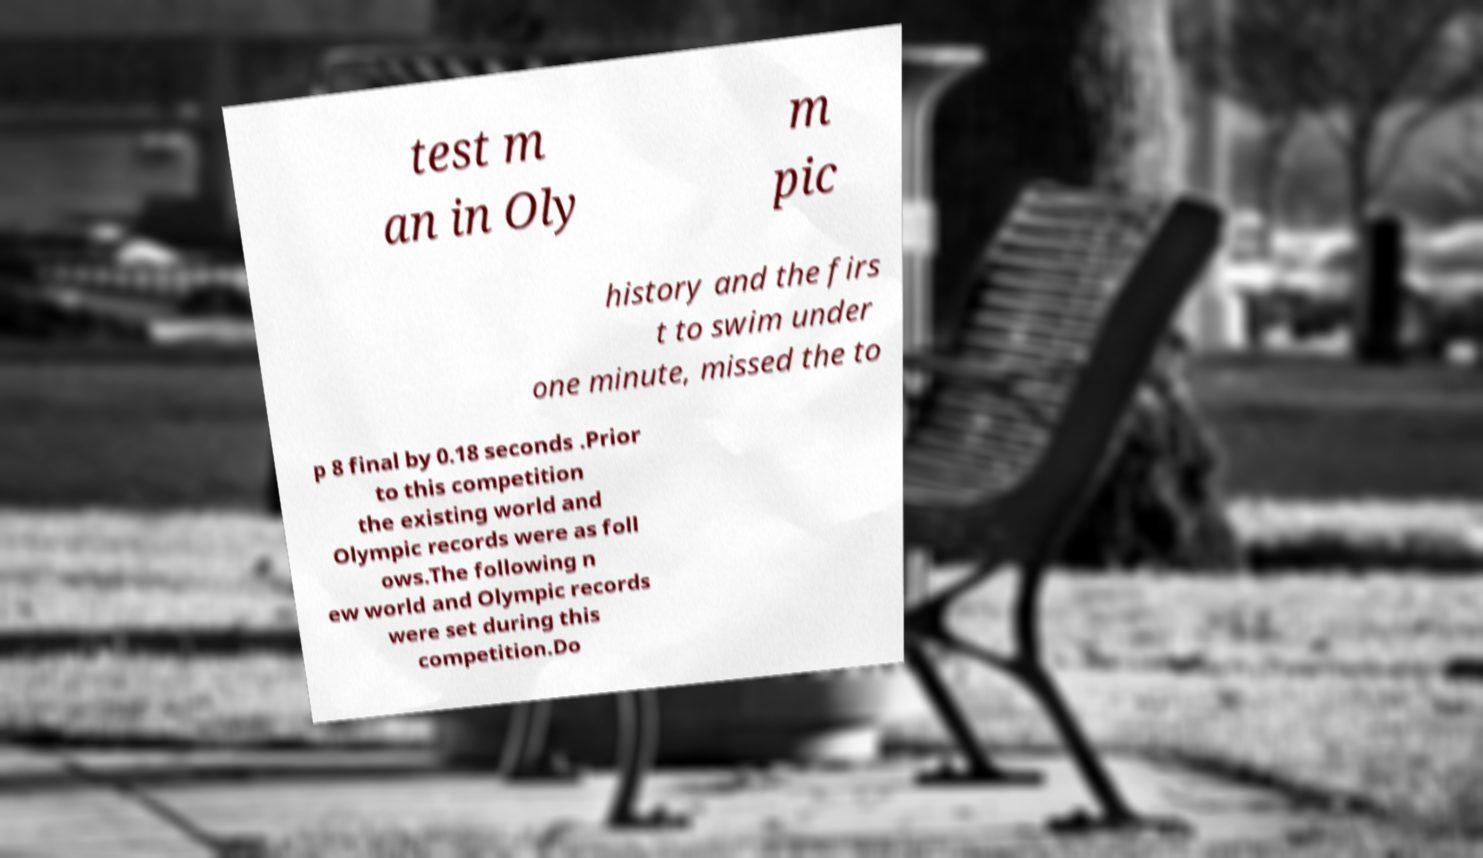Can you read and provide the text displayed in the image?This photo seems to have some interesting text. Can you extract and type it out for me? test m an in Oly m pic history and the firs t to swim under one minute, missed the to p 8 final by 0.18 seconds .Prior to this competition the existing world and Olympic records were as foll ows.The following n ew world and Olympic records were set during this competition.Do 